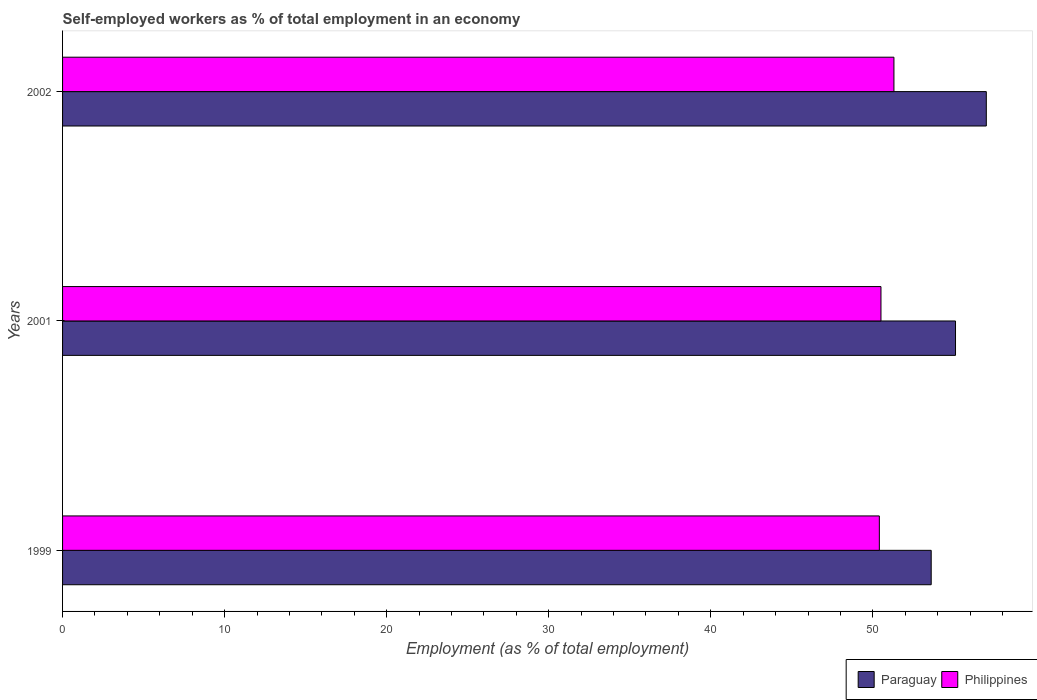How many groups of bars are there?
Your response must be concise. 3. Are the number of bars per tick equal to the number of legend labels?
Give a very brief answer. Yes. Are the number of bars on each tick of the Y-axis equal?
Offer a terse response. Yes. How many bars are there on the 1st tick from the bottom?
Provide a succinct answer. 2. What is the label of the 3rd group of bars from the top?
Offer a very short reply. 1999. In how many cases, is the number of bars for a given year not equal to the number of legend labels?
Keep it short and to the point. 0. What is the percentage of self-employed workers in Paraguay in 2002?
Offer a very short reply. 57. Across all years, what is the maximum percentage of self-employed workers in Paraguay?
Your response must be concise. 57. Across all years, what is the minimum percentage of self-employed workers in Paraguay?
Keep it short and to the point. 53.6. What is the total percentage of self-employed workers in Philippines in the graph?
Make the answer very short. 152.2. What is the difference between the percentage of self-employed workers in Paraguay in 2001 and that in 2002?
Offer a terse response. -1.9. What is the average percentage of self-employed workers in Paraguay per year?
Give a very brief answer. 55.23. In the year 2001, what is the difference between the percentage of self-employed workers in Paraguay and percentage of self-employed workers in Philippines?
Provide a short and direct response. 4.6. What is the ratio of the percentage of self-employed workers in Philippines in 1999 to that in 2002?
Your response must be concise. 0.98. What is the difference between the highest and the second highest percentage of self-employed workers in Philippines?
Ensure brevity in your answer.  0.8. What is the difference between the highest and the lowest percentage of self-employed workers in Paraguay?
Provide a short and direct response. 3.4. What does the 2nd bar from the top in 2001 represents?
Your response must be concise. Paraguay. What does the 1st bar from the bottom in 2001 represents?
Provide a short and direct response. Paraguay. Are all the bars in the graph horizontal?
Give a very brief answer. Yes. How many years are there in the graph?
Give a very brief answer. 3. Are the values on the major ticks of X-axis written in scientific E-notation?
Keep it short and to the point. No. How many legend labels are there?
Offer a terse response. 2. What is the title of the graph?
Give a very brief answer. Self-employed workers as % of total employment in an economy. What is the label or title of the X-axis?
Provide a short and direct response. Employment (as % of total employment). What is the Employment (as % of total employment) of Paraguay in 1999?
Provide a short and direct response. 53.6. What is the Employment (as % of total employment) of Philippines in 1999?
Give a very brief answer. 50.4. What is the Employment (as % of total employment) of Paraguay in 2001?
Keep it short and to the point. 55.1. What is the Employment (as % of total employment) of Philippines in 2001?
Give a very brief answer. 50.5. What is the Employment (as % of total employment) in Paraguay in 2002?
Offer a terse response. 57. What is the Employment (as % of total employment) in Philippines in 2002?
Your answer should be compact. 51.3. Across all years, what is the maximum Employment (as % of total employment) of Paraguay?
Your response must be concise. 57. Across all years, what is the maximum Employment (as % of total employment) of Philippines?
Offer a very short reply. 51.3. Across all years, what is the minimum Employment (as % of total employment) in Paraguay?
Your answer should be compact. 53.6. Across all years, what is the minimum Employment (as % of total employment) in Philippines?
Ensure brevity in your answer.  50.4. What is the total Employment (as % of total employment) of Paraguay in the graph?
Your response must be concise. 165.7. What is the total Employment (as % of total employment) in Philippines in the graph?
Ensure brevity in your answer.  152.2. What is the difference between the Employment (as % of total employment) in Paraguay in 1999 and that in 2002?
Offer a very short reply. -3.4. What is the difference between the Employment (as % of total employment) in Philippines in 1999 and that in 2002?
Keep it short and to the point. -0.9. What is the difference between the Employment (as % of total employment) in Paraguay in 2001 and that in 2002?
Make the answer very short. -1.9. What is the difference between the Employment (as % of total employment) in Philippines in 2001 and that in 2002?
Provide a succinct answer. -0.8. What is the difference between the Employment (as % of total employment) in Paraguay in 1999 and the Employment (as % of total employment) in Philippines in 2001?
Provide a short and direct response. 3.1. What is the difference between the Employment (as % of total employment) in Paraguay in 2001 and the Employment (as % of total employment) in Philippines in 2002?
Your answer should be very brief. 3.8. What is the average Employment (as % of total employment) of Paraguay per year?
Your answer should be very brief. 55.23. What is the average Employment (as % of total employment) in Philippines per year?
Your answer should be very brief. 50.73. What is the ratio of the Employment (as % of total employment) of Paraguay in 1999 to that in 2001?
Offer a very short reply. 0.97. What is the ratio of the Employment (as % of total employment) in Paraguay in 1999 to that in 2002?
Provide a succinct answer. 0.94. What is the ratio of the Employment (as % of total employment) of Philippines in 1999 to that in 2002?
Provide a short and direct response. 0.98. What is the ratio of the Employment (as % of total employment) of Paraguay in 2001 to that in 2002?
Give a very brief answer. 0.97. What is the ratio of the Employment (as % of total employment) in Philippines in 2001 to that in 2002?
Give a very brief answer. 0.98. What is the difference between the highest and the second highest Employment (as % of total employment) of Philippines?
Your response must be concise. 0.8. What is the difference between the highest and the lowest Employment (as % of total employment) of Paraguay?
Give a very brief answer. 3.4. 